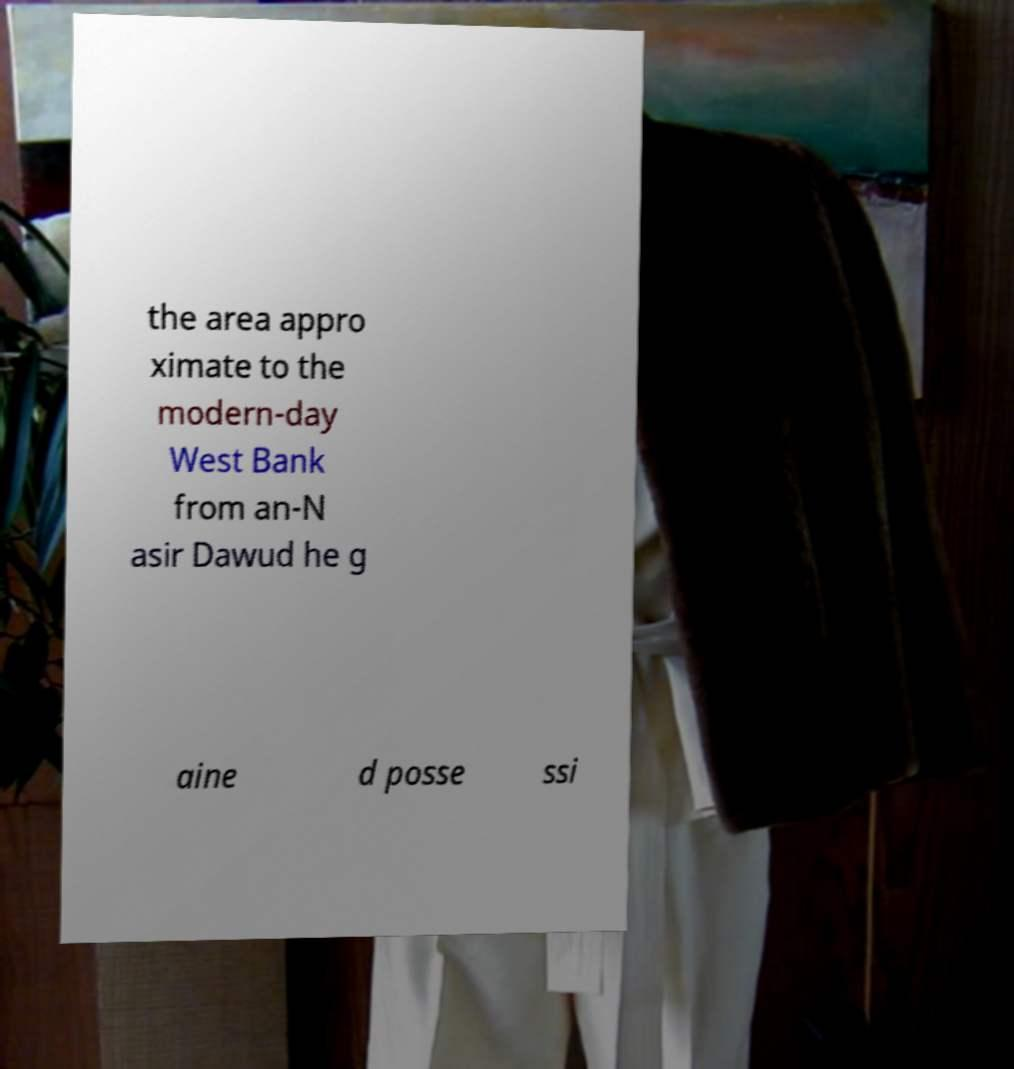Could you extract and type out the text from this image? the area appro ximate to the modern-day West Bank from an-N asir Dawud he g aine d posse ssi 